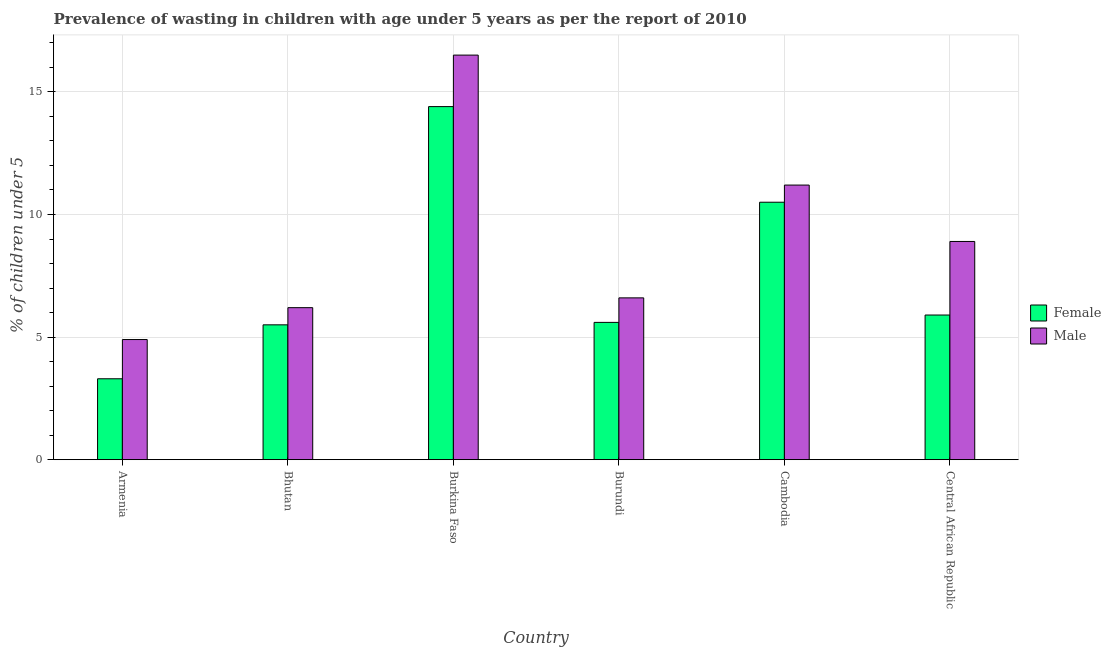How many different coloured bars are there?
Provide a succinct answer. 2. How many bars are there on the 6th tick from the right?
Make the answer very short. 2. What is the label of the 2nd group of bars from the left?
Your answer should be very brief. Bhutan. In how many cases, is the number of bars for a given country not equal to the number of legend labels?
Make the answer very short. 0. What is the percentage of undernourished male children in Bhutan?
Provide a succinct answer. 6.2. Across all countries, what is the maximum percentage of undernourished male children?
Provide a short and direct response. 16.5. Across all countries, what is the minimum percentage of undernourished female children?
Make the answer very short. 3.3. In which country was the percentage of undernourished male children maximum?
Give a very brief answer. Burkina Faso. In which country was the percentage of undernourished female children minimum?
Your answer should be compact. Armenia. What is the total percentage of undernourished female children in the graph?
Your response must be concise. 45.2. What is the difference between the percentage of undernourished female children in Armenia and that in Burkina Faso?
Your response must be concise. -11.1. What is the difference between the percentage of undernourished male children in Burkina Faso and the percentage of undernourished female children in Central African Republic?
Keep it short and to the point. 10.6. What is the average percentage of undernourished female children per country?
Offer a very short reply. 7.53. What is the difference between the percentage of undernourished female children and percentage of undernourished male children in Bhutan?
Give a very brief answer. -0.7. In how many countries, is the percentage of undernourished male children greater than 4 %?
Make the answer very short. 6. What is the ratio of the percentage of undernourished male children in Burundi to that in Central African Republic?
Your answer should be compact. 0.74. What is the difference between the highest and the second highest percentage of undernourished female children?
Make the answer very short. 3.9. What is the difference between the highest and the lowest percentage of undernourished female children?
Your answer should be compact. 11.1. In how many countries, is the percentage of undernourished male children greater than the average percentage of undernourished male children taken over all countries?
Your answer should be very brief. 2. Is the sum of the percentage of undernourished female children in Armenia and Cambodia greater than the maximum percentage of undernourished male children across all countries?
Give a very brief answer. No. What does the 2nd bar from the left in Armenia represents?
Offer a very short reply. Male. Are all the bars in the graph horizontal?
Your response must be concise. No. Are the values on the major ticks of Y-axis written in scientific E-notation?
Your response must be concise. No. Where does the legend appear in the graph?
Your response must be concise. Center right. How many legend labels are there?
Offer a terse response. 2. What is the title of the graph?
Your answer should be very brief. Prevalence of wasting in children with age under 5 years as per the report of 2010. Does "Methane emissions" appear as one of the legend labels in the graph?
Give a very brief answer. No. What is the label or title of the Y-axis?
Offer a terse response.  % of children under 5. What is the  % of children under 5 of Female in Armenia?
Offer a very short reply. 3.3. What is the  % of children under 5 of Male in Armenia?
Your response must be concise. 4.9. What is the  % of children under 5 of Female in Bhutan?
Provide a short and direct response. 5.5. What is the  % of children under 5 in Male in Bhutan?
Make the answer very short. 6.2. What is the  % of children under 5 in Female in Burkina Faso?
Provide a short and direct response. 14.4. What is the  % of children under 5 of Female in Burundi?
Keep it short and to the point. 5.6. What is the  % of children under 5 of Male in Burundi?
Offer a very short reply. 6.6. What is the  % of children under 5 in Female in Cambodia?
Your answer should be very brief. 10.5. What is the  % of children under 5 in Male in Cambodia?
Offer a terse response. 11.2. What is the  % of children under 5 of Female in Central African Republic?
Provide a succinct answer. 5.9. What is the  % of children under 5 in Male in Central African Republic?
Provide a succinct answer. 8.9. Across all countries, what is the maximum  % of children under 5 in Female?
Your answer should be very brief. 14.4. Across all countries, what is the minimum  % of children under 5 of Female?
Provide a succinct answer. 3.3. Across all countries, what is the minimum  % of children under 5 of Male?
Your answer should be very brief. 4.9. What is the total  % of children under 5 in Female in the graph?
Your answer should be very brief. 45.2. What is the total  % of children under 5 in Male in the graph?
Your response must be concise. 54.3. What is the difference between the  % of children under 5 of Female in Armenia and that in Bhutan?
Offer a terse response. -2.2. What is the difference between the  % of children under 5 of Male in Armenia and that in Bhutan?
Provide a short and direct response. -1.3. What is the difference between the  % of children under 5 in Female in Armenia and that in Burkina Faso?
Provide a succinct answer. -11.1. What is the difference between the  % of children under 5 of Male in Armenia and that in Burkina Faso?
Give a very brief answer. -11.6. What is the difference between the  % of children under 5 of Female in Armenia and that in Burundi?
Your answer should be compact. -2.3. What is the difference between the  % of children under 5 of Male in Armenia and that in Cambodia?
Your answer should be compact. -6.3. What is the difference between the  % of children under 5 in Female in Armenia and that in Central African Republic?
Provide a short and direct response. -2.6. What is the difference between the  % of children under 5 in Male in Armenia and that in Central African Republic?
Make the answer very short. -4. What is the difference between the  % of children under 5 of Female in Bhutan and that in Burkina Faso?
Your answer should be compact. -8.9. What is the difference between the  % of children under 5 of Female in Bhutan and that in Cambodia?
Ensure brevity in your answer.  -5. What is the difference between the  % of children under 5 in Female in Burkina Faso and that in Cambodia?
Offer a very short reply. 3.9. What is the difference between the  % of children under 5 in Male in Burkina Faso and that in Cambodia?
Your response must be concise. 5.3. What is the difference between the  % of children under 5 of Male in Burundi and that in Cambodia?
Ensure brevity in your answer.  -4.6. What is the difference between the  % of children under 5 of Female in Armenia and the  % of children under 5 of Male in Bhutan?
Provide a short and direct response. -2.9. What is the difference between the  % of children under 5 in Female in Armenia and the  % of children under 5 in Male in Burundi?
Your answer should be compact. -3.3. What is the difference between the  % of children under 5 of Female in Armenia and the  % of children under 5 of Male in Cambodia?
Give a very brief answer. -7.9. What is the difference between the  % of children under 5 of Female in Bhutan and the  % of children under 5 of Male in Central African Republic?
Provide a succinct answer. -3.4. What is the difference between the  % of children under 5 in Female in Burkina Faso and the  % of children under 5 in Male in Burundi?
Keep it short and to the point. 7.8. What is the difference between the  % of children under 5 in Female in Cambodia and the  % of children under 5 in Male in Central African Republic?
Ensure brevity in your answer.  1.6. What is the average  % of children under 5 of Female per country?
Provide a short and direct response. 7.53. What is the average  % of children under 5 of Male per country?
Offer a terse response. 9.05. What is the difference between the  % of children under 5 of Female and  % of children under 5 of Male in Armenia?
Offer a terse response. -1.6. What is the difference between the  % of children under 5 in Female and  % of children under 5 in Male in Burkina Faso?
Ensure brevity in your answer.  -2.1. What is the difference between the  % of children under 5 in Female and  % of children under 5 in Male in Burundi?
Your response must be concise. -1. What is the ratio of the  % of children under 5 of Male in Armenia to that in Bhutan?
Ensure brevity in your answer.  0.79. What is the ratio of the  % of children under 5 in Female in Armenia to that in Burkina Faso?
Your answer should be compact. 0.23. What is the ratio of the  % of children under 5 of Male in Armenia to that in Burkina Faso?
Keep it short and to the point. 0.3. What is the ratio of the  % of children under 5 in Female in Armenia to that in Burundi?
Offer a very short reply. 0.59. What is the ratio of the  % of children under 5 in Male in Armenia to that in Burundi?
Your answer should be very brief. 0.74. What is the ratio of the  % of children under 5 of Female in Armenia to that in Cambodia?
Ensure brevity in your answer.  0.31. What is the ratio of the  % of children under 5 of Male in Armenia to that in Cambodia?
Offer a very short reply. 0.44. What is the ratio of the  % of children under 5 in Female in Armenia to that in Central African Republic?
Your response must be concise. 0.56. What is the ratio of the  % of children under 5 of Male in Armenia to that in Central African Republic?
Provide a short and direct response. 0.55. What is the ratio of the  % of children under 5 in Female in Bhutan to that in Burkina Faso?
Offer a terse response. 0.38. What is the ratio of the  % of children under 5 of Male in Bhutan to that in Burkina Faso?
Your answer should be compact. 0.38. What is the ratio of the  % of children under 5 in Female in Bhutan to that in Burundi?
Keep it short and to the point. 0.98. What is the ratio of the  % of children under 5 of Male in Bhutan to that in Burundi?
Make the answer very short. 0.94. What is the ratio of the  % of children under 5 in Female in Bhutan to that in Cambodia?
Make the answer very short. 0.52. What is the ratio of the  % of children under 5 of Male in Bhutan to that in Cambodia?
Provide a succinct answer. 0.55. What is the ratio of the  % of children under 5 of Female in Bhutan to that in Central African Republic?
Provide a succinct answer. 0.93. What is the ratio of the  % of children under 5 of Male in Bhutan to that in Central African Republic?
Keep it short and to the point. 0.7. What is the ratio of the  % of children under 5 in Female in Burkina Faso to that in Burundi?
Provide a short and direct response. 2.57. What is the ratio of the  % of children under 5 in Male in Burkina Faso to that in Burundi?
Offer a terse response. 2.5. What is the ratio of the  % of children under 5 of Female in Burkina Faso to that in Cambodia?
Ensure brevity in your answer.  1.37. What is the ratio of the  % of children under 5 in Male in Burkina Faso to that in Cambodia?
Ensure brevity in your answer.  1.47. What is the ratio of the  % of children under 5 in Female in Burkina Faso to that in Central African Republic?
Ensure brevity in your answer.  2.44. What is the ratio of the  % of children under 5 of Male in Burkina Faso to that in Central African Republic?
Your response must be concise. 1.85. What is the ratio of the  % of children under 5 in Female in Burundi to that in Cambodia?
Provide a short and direct response. 0.53. What is the ratio of the  % of children under 5 in Male in Burundi to that in Cambodia?
Keep it short and to the point. 0.59. What is the ratio of the  % of children under 5 in Female in Burundi to that in Central African Republic?
Give a very brief answer. 0.95. What is the ratio of the  % of children under 5 of Male in Burundi to that in Central African Republic?
Your answer should be very brief. 0.74. What is the ratio of the  % of children under 5 in Female in Cambodia to that in Central African Republic?
Give a very brief answer. 1.78. What is the ratio of the  % of children under 5 in Male in Cambodia to that in Central African Republic?
Offer a terse response. 1.26. What is the difference between the highest and the second highest  % of children under 5 of Female?
Offer a terse response. 3.9. What is the difference between the highest and the second highest  % of children under 5 of Male?
Provide a succinct answer. 5.3. What is the difference between the highest and the lowest  % of children under 5 of Male?
Keep it short and to the point. 11.6. 